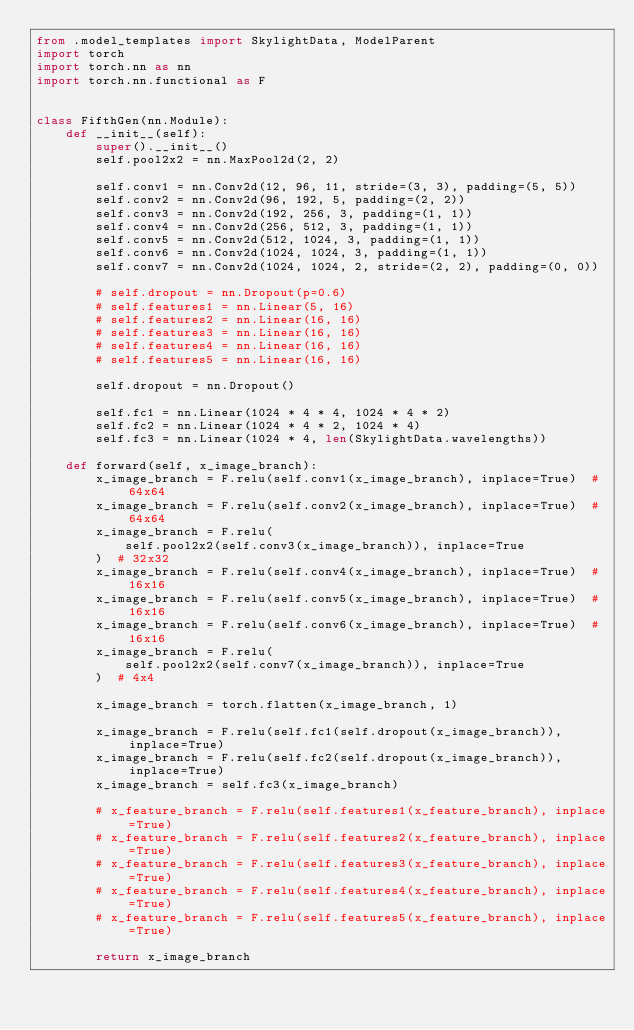<code> <loc_0><loc_0><loc_500><loc_500><_Python_>from .model_templates import SkylightData, ModelParent
import torch
import torch.nn as nn
import torch.nn.functional as F


class FifthGen(nn.Module):
    def __init__(self):
        super().__init__()
        self.pool2x2 = nn.MaxPool2d(2, 2)

        self.conv1 = nn.Conv2d(12, 96, 11, stride=(3, 3), padding=(5, 5))
        self.conv2 = nn.Conv2d(96, 192, 5, padding=(2, 2))
        self.conv3 = nn.Conv2d(192, 256, 3, padding=(1, 1))
        self.conv4 = nn.Conv2d(256, 512, 3, padding=(1, 1))
        self.conv5 = nn.Conv2d(512, 1024, 3, padding=(1, 1))
        self.conv6 = nn.Conv2d(1024, 1024, 3, padding=(1, 1))
        self.conv7 = nn.Conv2d(1024, 1024, 2, stride=(2, 2), padding=(0, 0))

        # self.dropout = nn.Dropout(p=0.6)
        # self.features1 = nn.Linear(5, 16)
        # self.features2 = nn.Linear(16, 16)
        # self.features3 = nn.Linear(16, 16)
        # self.features4 = nn.Linear(16, 16)
        # self.features5 = nn.Linear(16, 16)

        self.dropout = nn.Dropout()

        self.fc1 = nn.Linear(1024 * 4 * 4, 1024 * 4 * 2)
        self.fc2 = nn.Linear(1024 * 4 * 2, 1024 * 4)
        self.fc3 = nn.Linear(1024 * 4, len(SkylightData.wavelengths))

    def forward(self, x_image_branch):
        x_image_branch = F.relu(self.conv1(x_image_branch), inplace=True)  # 64x64
        x_image_branch = F.relu(self.conv2(x_image_branch), inplace=True)  # 64x64
        x_image_branch = F.relu(
            self.pool2x2(self.conv3(x_image_branch)), inplace=True
        )  # 32x32
        x_image_branch = F.relu(self.conv4(x_image_branch), inplace=True)  # 16x16
        x_image_branch = F.relu(self.conv5(x_image_branch), inplace=True)  # 16x16
        x_image_branch = F.relu(self.conv6(x_image_branch), inplace=True)  # 16x16
        x_image_branch = F.relu(
            self.pool2x2(self.conv7(x_image_branch)), inplace=True
        )  # 4x4

        x_image_branch = torch.flatten(x_image_branch, 1)

        x_image_branch = F.relu(self.fc1(self.dropout(x_image_branch)), inplace=True)
        x_image_branch = F.relu(self.fc2(self.dropout(x_image_branch)), inplace=True)
        x_image_branch = self.fc3(x_image_branch)

        # x_feature_branch = F.relu(self.features1(x_feature_branch), inplace=True)
        # x_feature_branch = F.relu(self.features2(x_feature_branch), inplace=True)
        # x_feature_branch = F.relu(self.features3(x_feature_branch), inplace=True)
        # x_feature_branch = F.relu(self.features4(x_feature_branch), inplace=True)
        # x_feature_branch = F.relu(self.features5(x_feature_branch), inplace=True)

        return x_image_branch
</code> 